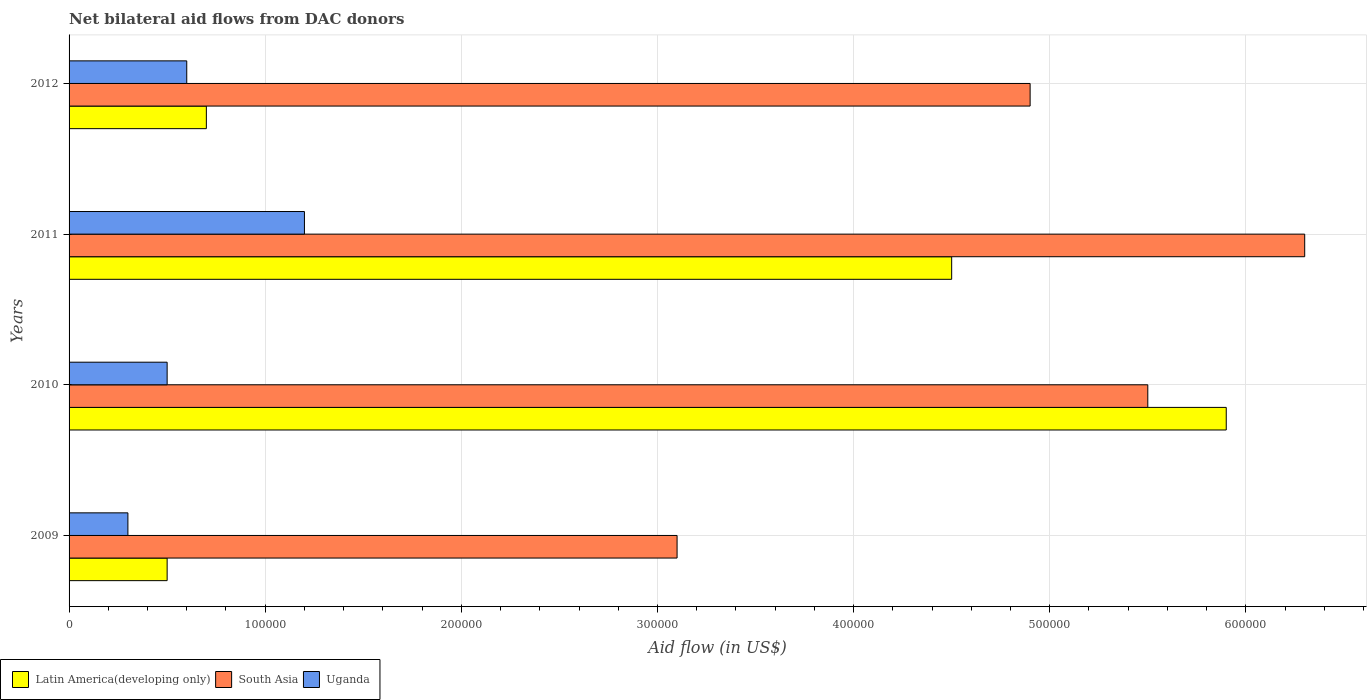Are the number of bars on each tick of the Y-axis equal?
Give a very brief answer. Yes. How many bars are there on the 2nd tick from the top?
Offer a terse response. 3. What is the label of the 3rd group of bars from the top?
Provide a succinct answer. 2010. In how many cases, is the number of bars for a given year not equal to the number of legend labels?
Your response must be concise. 0. Across all years, what is the maximum net bilateral aid flow in Latin America(developing only)?
Ensure brevity in your answer.  5.90e+05. Across all years, what is the minimum net bilateral aid flow in South Asia?
Your answer should be very brief. 3.10e+05. In which year was the net bilateral aid flow in Latin America(developing only) maximum?
Your answer should be very brief. 2010. What is the total net bilateral aid flow in Latin America(developing only) in the graph?
Your answer should be very brief. 1.16e+06. What is the difference between the net bilateral aid flow in Uganda in 2010 and that in 2012?
Keep it short and to the point. -10000. What is the difference between the net bilateral aid flow in Latin America(developing only) in 2010 and the net bilateral aid flow in South Asia in 2012?
Offer a very short reply. 1.00e+05. What is the average net bilateral aid flow in Uganda per year?
Provide a succinct answer. 6.50e+04. What is the ratio of the net bilateral aid flow in Latin America(developing only) in 2010 to that in 2011?
Provide a succinct answer. 1.31. Is the net bilateral aid flow in South Asia in 2009 less than that in 2011?
Your response must be concise. Yes. Is the difference between the net bilateral aid flow in Uganda in 2010 and 2011 greater than the difference between the net bilateral aid flow in Latin America(developing only) in 2010 and 2011?
Ensure brevity in your answer.  No. What is the difference between the highest and the lowest net bilateral aid flow in Uganda?
Your response must be concise. 9.00e+04. In how many years, is the net bilateral aid flow in South Asia greater than the average net bilateral aid flow in South Asia taken over all years?
Your answer should be compact. 2. Is the sum of the net bilateral aid flow in Uganda in 2010 and 2011 greater than the maximum net bilateral aid flow in Latin America(developing only) across all years?
Provide a short and direct response. No. What does the 2nd bar from the top in 2009 represents?
Provide a short and direct response. South Asia. What does the 2nd bar from the bottom in 2011 represents?
Your response must be concise. South Asia. Are all the bars in the graph horizontal?
Your response must be concise. Yes. Does the graph contain grids?
Make the answer very short. Yes. Where does the legend appear in the graph?
Provide a succinct answer. Bottom left. How many legend labels are there?
Make the answer very short. 3. What is the title of the graph?
Your answer should be very brief. Net bilateral aid flows from DAC donors. What is the label or title of the X-axis?
Offer a very short reply. Aid flow (in US$). What is the Aid flow (in US$) of Latin America(developing only) in 2009?
Keep it short and to the point. 5.00e+04. What is the Aid flow (in US$) in South Asia in 2009?
Give a very brief answer. 3.10e+05. What is the Aid flow (in US$) in Uganda in 2009?
Your answer should be compact. 3.00e+04. What is the Aid flow (in US$) in Latin America(developing only) in 2010?
Ensure brevity in your answer.  5.90e+05. What is the Aid flow (in US$) of Uganda in 2010?
Your response must be concise. 5.00e+04. What is the Aid flow (in US$) in Latin America(developing only) in 2011?
Your answer should be very brief. 4.50e+05. What is the Aid flow (in US$) of South Asia in 2011?
Make the answer very short. 6.30e+05. What is the Aid flow (in US$) of South Asia in 2012?
Offer a terse response. 4.90e+05. What is the Aid flow (in US$) of Uganda in 2012?
Provide a succinct answer. 6.00e+04. Across all years, what is the maximum Aid flow (in US$) of Latin America(developing only)?
Keep it short and to the point. 5.90e+05. Across all years, what is the maximum Aid flow (in US$) of South Asia?
Your answer should be compact. 6.30e+05. Across all years, what is the maximum Aid flow (in US$) of Uganda?
Make the answer very short. 1.20e+05. Across all years, what is the minimum Aid flow (in US$) of Latin America(developing only)?
Provide a succinct answer. 5.00e+04. Across all years, what is the minimum Aid flow (in US$) of Uganda?
Make the answer very short. 3.00e+04. What is the total Aid flow (in US$) of Latin America(developing only) in the graph?
Make the answer very short. 1.16e+06. What is the total Aid flow (in US$) in South Asia in the graph?
Give a very brief answer. 1.98e+06. What is the total Aid flow (in US$) in Uganda in the graph?
Your answer should be compact. 2.60e+05. What is the difference between the Aid flow (in US$) of Latin America(developing only) in 2009 and that in 2010?
Keep it short and to the point. -5.40e+05. What is the difference between the Aid flow (in US$) in South Asia in 2009 and that in 2010?
Your response must be concise. -2.40e+05. What is the difference between the Aid flow (in US$) in Latin America(developing only) in 2009 and that in 2011?
Your answer should be very brief. -4.00e+05. What is the difference between the Aid flow (in US$) in South Asia in 2009 and that in 2011?
Offer a very short reply. -3.20e+05. What is the difference between the Aid flow (in US$) in Uganda in 2009 and that in 2011?
Ensure brevity in your answer.  -9.00e+04. What is the difference between the Aid flow (in US$) in Latin America(developing only) in 2009 and that in 2012?
Offer a terse response. -2.00e+04. What is the difference between the Aid flow (in US$) of South Asia in 2009 and that in 2012?
Offer a very short reply. -1.80e+05. What is the difference between the Aid flow (in US$) in Uganda in 2009 and that in 2012?
Give a very brief answer. -3.00e+04. What is the difference between the Aid flow (in US$) in Latin America(developing only) in 2010 and that in 2011?
Ensure brevity in your answer.  1.40e+05. What is the difference between the Aid flow (in US$) in South Asia in 2010 and that in 2011?
Your response must be concise. -8.00e+04. What is the difference between the Aid flow (in US$) of Latin America(developing only) in 2010 and that in 2012?
Your response must be concise. 5.20e+05. What is the difference between the Aid flow (in US$) in South Asia in 2010 and that in 2012?
Offer a terse response. 6.00e+04. What is the difference between the Aid flow (in US$) of South Asia in 2011 and that in 2012?
Offer a terse response. 1.40e+05. What is the difference between the Aid flow (in US$) in Uganda in 2011 and that in 2012?
Offer a terse response. 6.00e+04. What is the difference between the Aid flow (in US$) in Latin America(developing only) in 2009 and the Aid flow (in US$) in South Asia in 2010?
Ensure brevity in your answer.  -5.00e+05. What is the difference between the Aid flow (in US$) in Latin America(developing only) in 2009 and the Aid flow (in US$) in South Asia in 2011?
Provide a short and direct response. -5.80e+05. What is the difference between the Aid flow (in US$) of Latin America(developing only) in 2009 and the Aid flow (in US$) of Uganda in 2011?
Offer a very short reply. -7.00e+04. What is the difference between the Aid flow (in US$) of Latin America(developing only) in 2009 and the Aid flow (in US$) of South Asia in 2012?
Ensure brevity in your answer.  -4.40e+05. What is the difference between the Aid flow (in US$) in Latin America(developing only) in 2009 and the Aid flow (in US$) in Uganda in 2012?
Offer a terse response. -10000. What is the difference between the Aid flow (in US$) of South Asia in 2009 and the Aid flow (in US$) of Uganda in 2012?
Your answer should be compact. 2.50e+05. What is the difference between the Aid flow (in US$) in Latin America(developing only) in 2010 and the Aid flow (in US$) in Uganda in 2011?
Offer a terse response. 4.70e+05. What is the difference between the Aid flow (in US$) in Latin America(developing only) in 2010 and the Aid flow (in US$) in Uganda in 2012?
Offer a terse response. 5.30e+05. What is the difference between the Aid flow (in US$) of Latin America(developing only) in 2011 and the Aid flow (in US$) of South Asia in 2012?
Ensure brevity in your answer.  -4.00e+04. What is the difference between the Aid flow (in US$) of South Asia in 2011 and the Aid flow (in US$) of Uganda in 2012?
Your answer should be compact. 5.70e+05. What is the average Aid flow (in US$) in South Asia per year?
Make the answer very short. 4.95e+05. What is the average Aid flow (in US$) in Uganda per year?
Your response must be concise. 6.50e+04. In the year 2009, what is the difference between the Aid flow (in US$) in Latin America(developing only) and Aid flow (in US$) in Uganda?
Keep it short and to the point. 2.00e+04. In the year 2010, what is the difference between the Aid flow (in US$) in Latin America(developing only) and Aid flow (in US$) in South Asia?
Ensure brevity in your answer.  4.00e+04. In the year 2010, what is the difference between the Aid flow (in US$) of Latin America(developing only) and Aid flow (in US$) of Uganda?
Your answer should be compact. 5.40e+05. In the year 2011, what is the difference between the Aid flow (in US$) in Latin America(developing only) and Aid flow (in US$) in South Asia?
Your answer should be compact. -1.80e+05. In the year 2011, what is the difference between the Aid flow (in US$) of Latin America(developing only) and Aid flow (in US$) of Uganda?
Your response must be concise. 3.30e+05. In the year 2011, what is the difference between the Aid flow (in US$) of South Asia and Aid flow (in US$) of Uganda?
Provide a succinct answer. 5.10e+05. In the year 2012, what is the difference between the Aid flow (in US$) in Latin America(developing only) and Aid flow (in US$) in South Asia?
Give a very brief answer. -4.20e+05. What is the ratio of the Aid flow (in US$) of Latin America(developing only) in 2009 to that in 2010?
Your answer should be very brief. 0.08. What is the ratio of the Aid flow (in US$) in South Asia in 2009 to that in 2010?
Keep it short and to the point. 0.56. What is the ratio of the Aid flow (in US$) in Uganda in 2009 to that in 2010?
Your response must be concise. 0.6. What is the ratio of the Aid flow (in US$) of South Asia in 2009 to that in 2011?
Provide a succinct answer. 0.49. What is the ratio of the Aid flow (in US$) in Uganda in 2009 to that in 2011?
Provide a short and direct response. 0.25. What is the ratio of the Aid flow (in US$) of South Asia in 2009 to that in 2012?
Give a very brief answer. 0.63. What is the ratio of the Aid flow (in US$) of Latin America(developing only) in 2010 to that in 2011?
Your answer should be very brief. 1.31. What is the ratio of the Aid flow (in US$) of South Asia in 2010 to that in 2011?
Make the answer very short. 0.87. What is the ratio of the Aid flow (in US$) in Uganda in 2010 to that in 2011?
Offer a very short reply. 0.42. What is the ratio of the Aid flow (in US$) in Latin America(developing only) in 2010 to that in 2012?
Ensure brevity in your answer.  8.43. What is the ratio of the Aid flow (in US$) in South Asia in 2010 to that in 2012?
Your response must be concise. 1.12. What is the ratio of the Aid flow (in US$) in Latin America(developing only) in 2011 to that in 2012?
Provide a succinct answer. 6.43. What is the difference between the highest and the second highest Aid flow (in US$) of Latin America(developing only)?
Provide a short and direct response. 1.40e+05. What is the difference between the highest and the lowest Aid flow (in US$) of Latin America(developing only)?
Your answer should be compact. 5.40e+05. What is the difference between the highest and the lowest Aid flow (in US$) of South Asia?
Your answer should be very brief. 3.20e+05. 